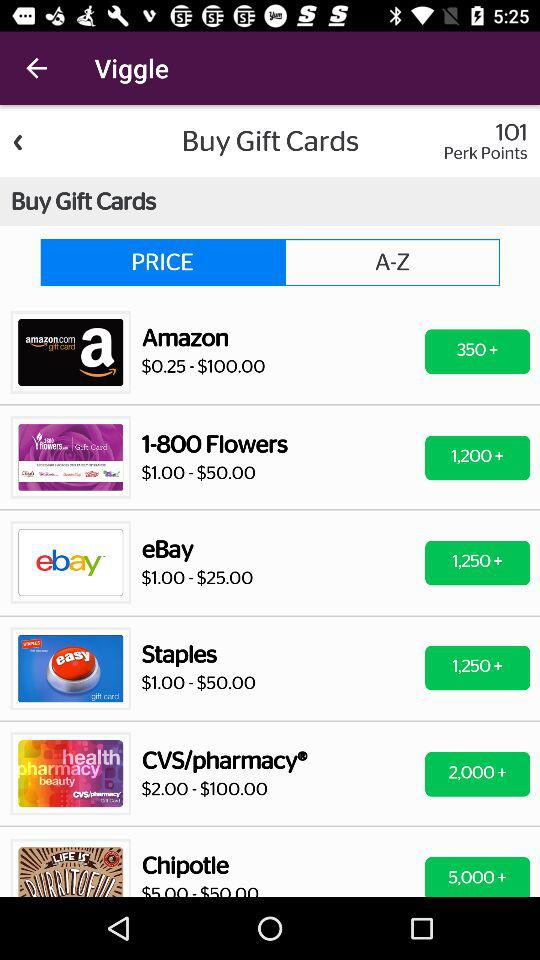At what available price can a Staples gift card be bought? The available price is from $1.00 to $50.00. 